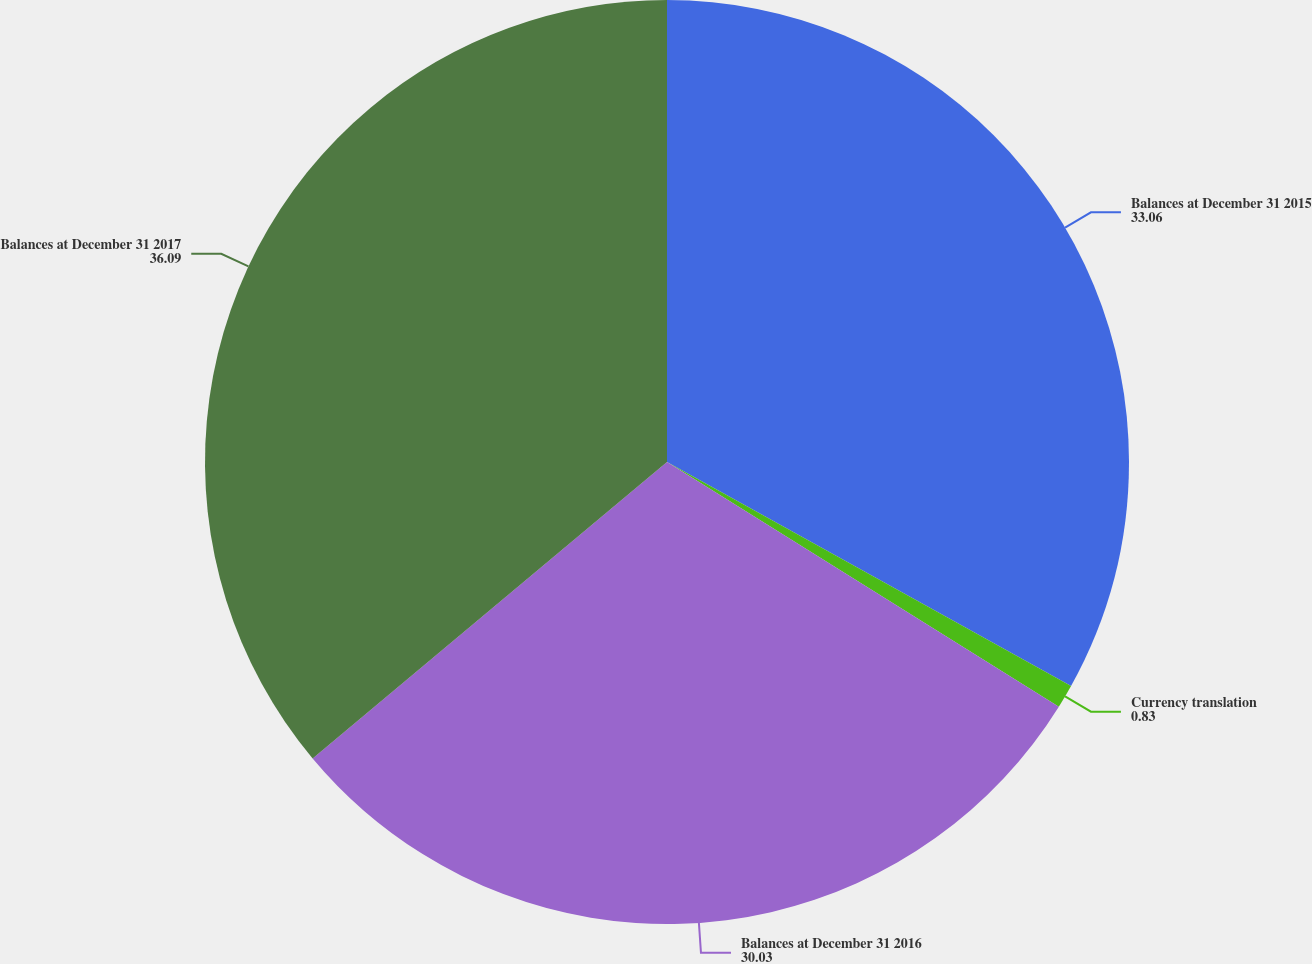Convert chart to OTSL. <chart><loc_0><loc_0><loc_500><loc_500><pie_chart><fcel>Balances at December 31 2015<fcel>Currency translation<fcel>Balances at December 31 2016<fcel>Balances at December 31 2017<nl><fcel>33.06%<fcel>0.83%<fcel>30.03%<fcel>36.09%<nl></chart> 